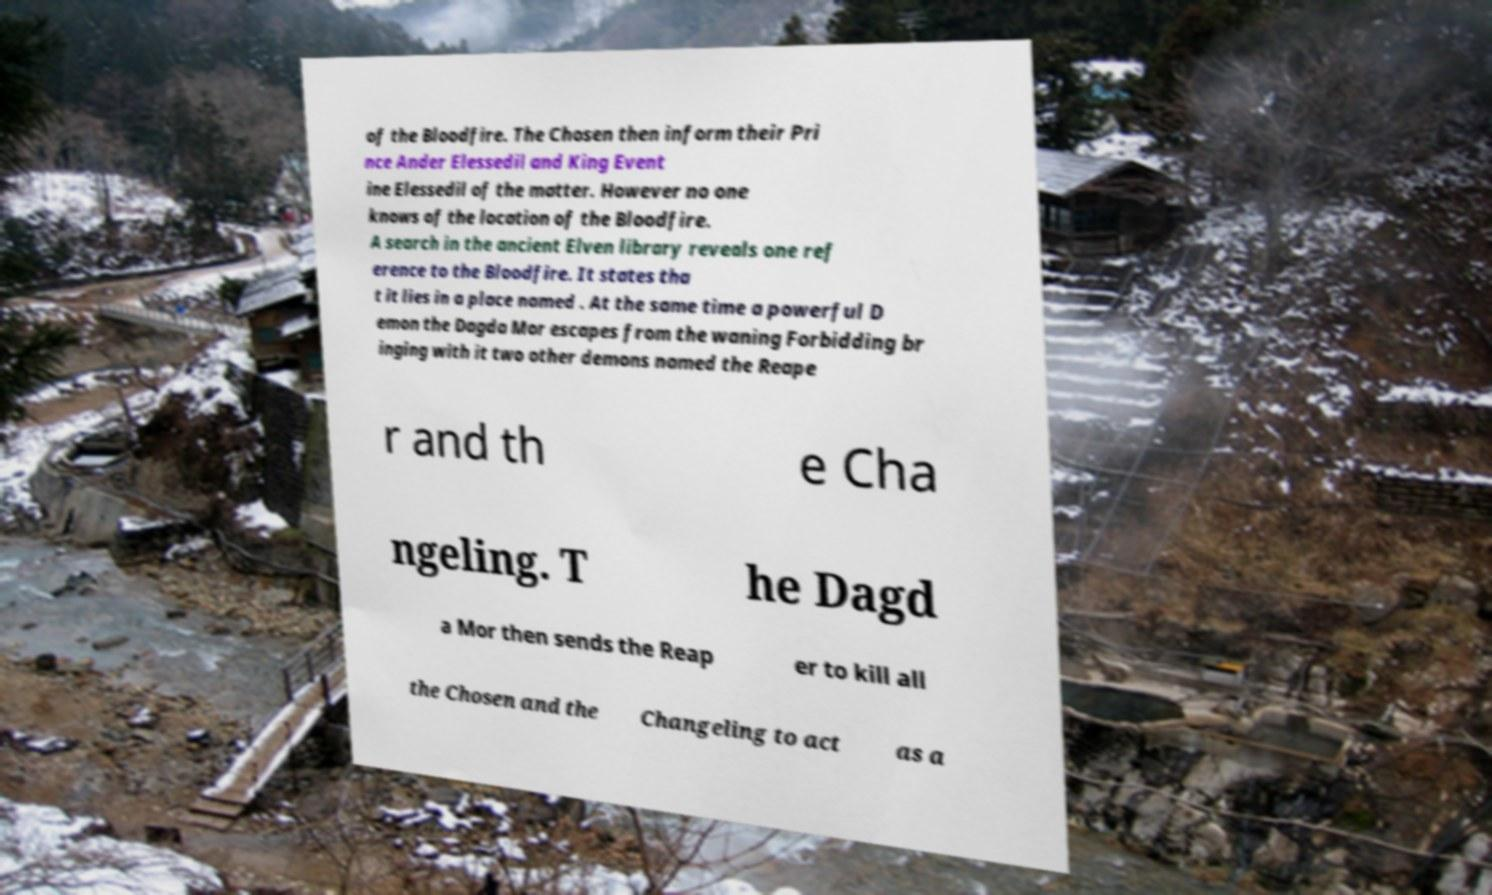I need the written content from this picture converted into text. Can you do that? of the Bloodfire. The Chosen then inform their Pri nce Ander Elessedil and King Event ine Elessedil of the matter. However no one knows of the location of the Bloodfire. A search in the ancient Elven library reveals one ref erence to the Bloodfire. It states tha t it lies in a place named . At the same time a powerful D emon the Dagda Mor escapes from the waning Forbidding br inging with it two other demons named the Reape r and th e Cha ngeling. T he Dagd a Mor then sends the Reap er to kill all the Chosen and the Changeling to act as a 